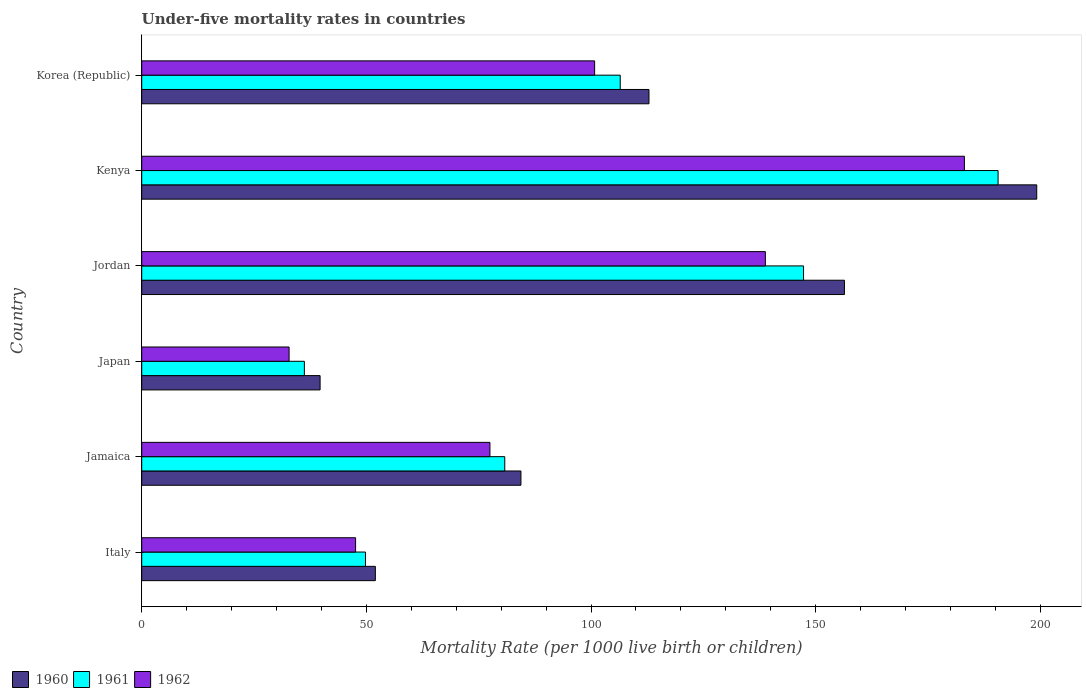How many different coloured bars are there?
Provide a succinct answer. 3. What is the label of the 5th group of bars from the top?
Your answer should be compact. Jamaica. In how many cases, is the number of bars for a given country not equal to the number of legend labels?
Provide a succinct answer. 0. What is the under-five mortality rate in 1960 in Japan?
Your answer should be very brief. 39.7. Across all countries, what is the maximum under-five mortality rate in 1962?
Provide a succinct answer. 183.1. Across all countries, what is the minimum under-five mortality rate in 1961?
Your response must be concise. 36.2. In which country was the under-five mortality rate in 1962 maximum?
Your answer should be very brief. Kenya. What is the total under-five mortality rate in 1960 in the graph?
Keep it short and to the point. 644.6. What is the difference between the under-five mortality rate in 1961 in Jamaica and that in Jordan?
Offer a very short reply. -66.5. What is the difference between the under-five mortality rate in 1962 in Jordan and the under-five mortality rate in 1960 in Jamaica?
Your answer should be compact. 54.4. What is the average under-five mortality rate in 1960 per country?
Your response must be concise. 107.43. What is the difference between the under-five mortality rate in 1962 and under-five mortality rate in 1961 in Korea (Republic)?
Provide a succinct answer. -5.7. In how many countries, is the under-five mortality rate in 1961 greater than 90 ?
Keep it short and to the point. 3. What is the ratio of the under-five mortality rate in 1962 in Jamaica to that in Korea (Republic)?
Your answer should be compact. 0.77. Is the under-five mortality rate in 1962 in Kenya less than that in Korea (Republic)?
Your answer should be compact. No. What is the difference between the highest and the second highest under-five mortality rate in 1960?
Your answer should be very brief. 42.8. What is the difference between the highest and the lowest under-five mortality rate in 1962?
Make the answer very short. 150.3. Is the sum of the under-five mortality rate in 1961 in Italy and Jamaica greater than the maximum under-five mortality rate in 1960 across all countries?
Offer a terse response. No. What does the 1st bar from the top in Kenya represents?
Keep it short and to the point. 1962. What does the 2nd bar from the bottom in Japan represents?
Your answer should be very brief. 1961. Is it the case that in every country, the sum of the under-five mortality rate in 1960 and under-five mortality rate in 1962 is greater than the under-five mortality rate in 1961?
Keep it short and to the point. Yes. Are all the bars in the graph horizontal?
Ensure brevity in your answer.  Yes. How many countries are there in the graph?
Your response must be concise. 6. What is the difference between two consecutive major ticks on the X-axis?
Your answer should be compact. 50. Does the graph contain any zero values?
Make the answer very short. No. What is the title of the graph?
Ensure brevity in your answer.  Under-five mortality rates in countries. What is the label or title of the X-axis?
Give a very brief answer. Mortality Rate (per 1000 live birth or children). What is the Mortality Rate (per 1000 live birth or children) of 1960 in Italy?
Provide a short and direct response. 52. What is the Mortality Rate (per 1000 live birth or children) of 1961 in Italy?
Provide a succinct answer. 49.8. What is the Mortality Rate (per 1000 live birth or children) in 1962 in Italy?
Your response must be concise. 47.6. What is the Mortality Rate (per 1000 live birth or children) of 1960 in Jamaica?
Make the answer very short. 84.4. What is the Mortality Rate (per 1000 live birth or children) in 1961 in Jamaica?
Ensure brevity in your answer.  80.8. What is the Mortality Rate (per 1000 live birth or children) of 1962 in Jamaica?
Ensure brevity in your answer.  77.5. What is the Mortality Rate (per 1000 live birth or children) in 1960 in Japan?
Ensure brevity in your answer.  39.7. What is the Mortality Rate (per 1000 live birth or children) of 1961 in Japan?
Offer a very short reply. 36.2. What is the Mortality Rate (per 1000 live birth or children) in 1962 in Japan?
Give a very brief answer. 32.8. What is the Mortality Rate (per 1000 live birth or children) of 1960 in Jordan?
Your answer should be compact. 156.4. What is the Mortality Rate (per 1000 live birth or children) in 1961 in Jordan?
Keep it short and to the point. 147.3. What is the Mortality Rate (per 1000 live birth or children) of 1962 in Jordan?
Your response must be concise. 138.8. What is the Mortality Rate (per 1000 live birth or children) in 1960 in Kenya?
Keep it short and to the point. 199.2. What is the Mortality Rate (per 1000 live birth or children) in 1961 in Kenya?
Give a very brief answer. 190.6. What is the Mortality Rate (per 1000 live birth or children) in 1962 in Kenya?
Offer a very short reply. 183.1. What is the Mortality Rate (per 1000 live birth or children) in 1960 in Korea (Republic)?
Make the answer very short. 112.9. What is the Mortality Rate (per 1000 live birth or children) of 1961 in Korea (Republic)?
Offer a terse response. 106.5. What is the Mortality Rate (per 1000 live birth or children) of 1962 in Korea (Republic)?
Offer a very short reply. 100.8. Across all countries, what is the maximum Mortality Rate (per 1000 live birth or children) in 1960?
Your response must be concise. 199.2. Across all countries, what is the maximum Mortality Rate (per 1000 live birth or children) in 1961?
Your answer should be very brief. 190.6. Across all countries, what is the maximum Mortality Rate (per 1000 live birth or children) of 1962?
Your answer should be very brief. 183.1. Across all countries, what is the minimum Mortality Rate (per 1000 live birth or children) of 1960?
Give a very brief answer. 39.7. Across all countries, what is the minimum Mortality Rate (per 1000 live birth or children) in 1961?
Provide a succinct answer. 36.2. Across all countries, what is the minimum Mortality Rate (per 1000 live birth or children) of 1962?
Keep it short and to the point. 32.8. What is the total Mortality Rate (per 1000 live birth or children) of 1960 in the graph?
Ensure brevity in your answer.  644.6. What is the total Mortality Rate (per 1000 live birth or children) in 1961 in the graph?
Ensure brevity in your answer.  611.2. What is the total Mortality Rate (per 1000 live birth or children) in 1962 in the graph?
Your response must be concise. 580.6. What is the difference between the Mortality Rate (per 1000 live birth or children) in 1960 in Italy and that in Jamaica?
Your answer should be very brief. -32.4. What is the difference between the Mortality Rate (per 1000 live birth or children) of 1961 in Italy and that in Jamaica?
Give a very brief answer. -31. What is the difference between the Mortality Rate (per 1000 live birth or children) of 1962 in Italy and that in Jamaica?
Keep it short and to the point. -29.9. What is the difference between the Mortality Rate (per 1000 live birth or children) of 1961 in Italy and that in Japan?
Your response must be concise. 13.6. What is the difference between the Mortality Rate (per 1000 live birth or children) in 1962 in Italy and that in Japan?
Ensure brevity in your answer.  14.8. What is the difference between the Mortality Rate (per 1000 live birth or children) of 1960 in Italy and that in Jordan?
Give a very brief answer. -104.4. What is the difference between the Mortality Rate (per 1000 live birth or children) of 1961 in Italy and that in Jordan?
Your answer should be compact. -97.5. What is the difference between the Mortality Rate (per 1000 live birth or children) of 1962 in Italy and that in Jordan?
Make the answer very short. -91.2. What is the difference between the Mortality Rate (per 1000 live birth or children) of 1960 in Italy and that in Kenya?
Provide a succinct answer. -147.2. What is the difference between the Mortality Rate (per 1000 live birth or children) of 1961 in Italy and that in Kenya?
Your answer should be very brief. -140.8. What is the difference between the Mortality Rate (per 1000 live birth or children) of 1962 in Italy and that in Kenya?
Your answer should be very brief. -135.5. What is the difference between the Mortality Rate (per 1000 live birth or children) of 1960 in Italy and that in Korea (Republic)?
Ensure brevity in your answer.  -60.9. What is the difference between the Mortality Rate (per 1000 live birth or children) in 1961 in Italy and that in Korea (Republic)?
Give a very brief answer. -56.7. What is the difference between the Mortality Rate (per 1000 live birth or children) in 1962 in Italy and that in Korea (Republic)?
Ensure brevity in your answer.  -53.2. What is the difference between the Mortality Rate (per 1000 live birth or children) in 1960 in Jamaica and that in Japan?
Provide a succinct answer. 44.7. What is the difference between the Mortality Rate (per 1000 live birth or children) of 1961 in Jamaica and that in Japan?
Your answer should be compact. 44.6. What is the difference between the Mortality Rate (per 1000 live birth or children) of 1962 in Jamaica and that in Japan?
Your answer should be very brief. 44.7. What is the difference between the Mortality Rate (per 1000 live birth or children) in 1960 in Jamaica and that in Jordan?
Provide a short and direct response. -72. What is the difference between the Mortality Rate (per 1000 live birth or children) in 1961 in Jamaica and that in Jordan?
Keep it short and to the point. -66.5. What is the difference between the Mortality Rate (per 1000 live birth or children) of 1962 in Jamaica and that in Jordan?
Your answer should be compact. -61.3. What is the difference between the Mortality Rate (per 1000 live birth or children) of 1960 in Jamaica and that in Kenya?
Ensure brevity in your answer.  -114.8. What is the difference between the Mortality Rate (per 1000 live birth or children) of 1961 in Jamaica and that in Kenya?
Ensure brevity in your answer.  -109.8. What is the difference between the Mortality Rate (per 1000 live birth or children) in 1962 in Jamaica and that in Kenya?
Offer a terse response. -105.6. What is the difference between the Mortality Rate (per 1000 live birth or children) in 1960 in Jamaica and that in Korea (Republic)?
Provide a short and direct response. -28.5. What is the difference between the Mortality Rate (per 1000 live birth or children) of 1961 in Jamaica and that in Korea (Republic)?
Offer a very short reply. -25.7. What is the difference between the Mortality Rate (per 1000 live birth or children) in 1962 in Jamaica and that in Korea (Republic)?
Your answer should be compact. -23.3. What is the difference between the Mortality Rate (per 1000 live birth or children) of 1960 in Japan and that in Jordan?
Provide a short and direct response. -116.7. What is the difference between the Mortality Rate (per 1000 live birth or children) of 1961 in Japan and that in Jordan?
Provide a succinct answer. -111.1. What is the difference between the Mortality Rate (per 1000 live birth or children) in 1962 in Japan and that in Jordan?
Your response must be concise. -106. What is the difference between the Mortality Rate (per 1000 live birth or children) of 1960 in Japan and that in Kenya?
Provide a short and direct response. -159.5. What is the difference between the Mortality Rate (per 1000 live birth or children) in 1961 in Japan and that in Kenya?
Provide a succinct answer. -154.4. What is the difference between the Mortality Rate (per 1000 live birth or children) of 1962 in Japan and that in Kenya?
Give a very brief answer. -150.3. What is the difference between the Mortality Rate (per 1000 live birth or children) of 1960 in Japan and that in Korea (Republic)?
Keep it short and to the point. -73.2. What is the difference between the Mortality Rate (per 1000 live birth or children) in 1961 in Japan and that in Korea (Republic)?
Offer a very short reply. -70.3. What is the difference between the Mortality Rate (per 1000 live birth or children) of 1962 in Japan and that in Korea (Republic)?
Offer a terse response. -68. What is the difference between the Mortality Rate (per 1000 live birth or children) in 1960 in Jordan and that in Kenya?
Provide a succinct answer. -42.8. What is the difference between the Mortality Rate (per 1000 live birth or children) in 1961 in Jordan and that in Kenya?
Your answer should be very brief. -43.3. What is the difference between the Mortality Rate (per 1000 live birth or children) of 1962 in Jordan and that in Kenya?
Offer a very short reply. -44.3. What is the difference between the Mortality Rate (per 1000 live birth or children) of 1960 in Jordan and that in Korea (Republic)?
Your answer should be compact. 43.5. What is the difference between the Mortality Rate (per 1000 live birth or children) in 1961 in Jordan and that in Korea (Republic)?
Provide a short and direct response. 40.8. What is the difference between the Mortality Rate (per 1000 live birth or children) of 1962 in Jordan and that in Korea (Republic)?
Your answer should be very brief. 38. What is the difference between the Mortality Rate (per 1000 live birth or children) of 1960 in Kenya and that in Korea (Republic)?
Provide a succinct answer. 86.3. What is the difference between the Mortality Rate (per 1000 live birth or children) of 1961 in Kenya and that in Korea (Republic)?
Keep it short and to the point. 84.1. What is the difference between the Mortality Rate (per 1000 live birth or children) of 1962 in Kenya and that in Korea (Republic)?
Your answer should be very brief. 82.3. What is the difference between the Mortality Rate (per 1000 live birth or children) of 1960 in Italy and the Mortality Rate (per 1000 live birth or children) of 1961 in Jamaica?
Provide a short and direct response. -28.8. What is the difference between the Mortality Rate (per 1000 live birth or children) of 1960 in Italy and the Mortality Rate (per 1000 live birth or children) of 1962 in Jamaica?
Ensure brevity in your answer.  -25.5. What is the difference between the Mortality Rate (per 1000 live birth or children) in 1961 in Italy and the Mortality Rate (per 1000 live birth or children) in 1962 in Jamaica?
Give a very brief answer. -27.7. What is the difference between the Mortality Rate (per 1000 live birth or children) of 1960 in Italy and the Mortality Rate (per 1000 live birth or children) of 1961 in Jordan?
Your answer should be compact. -95.3. What is the difference between the Mortality Rate (per 1000 live birth or children) in 1960 in Italy and the Mortality Rate (per 1000 live birth or children) in 1962 in Jordan?
Offer a terse response. -86.8. What is the difference between the Mortality Rate (per 1000 live birth or children) of 1961 in Italy and the Mortality Rate (per 1000 live birth or children) of 1962 in Jordan?
Your answer should be compact. -89. What is the difference between the Mortality Rate (per 1000 live birth or children) of 1960 in Italy and the Mortality Rate (per 1000 live birth or children) of 1961 in Kenya?
Keep it short and to the point. -138.6. What is the difference between the Mortality Rate (per 1000 live birth or children) of 1960 in Italy and the Mortality Rate (per 1000 live birth or children) of 1962 in Kenya?
Ensure brevity in your answer.  -131.1. What is the difference between the Mortality Rate (per 1000 live birth or children) of 1961 in Italy and the Mortality Rate (per 1000 live birth or children) of 1962 in Kenya?
Give a very brief answer. -133.3. What is the difference between the Mortality Rate (per 1000 live birth or children) of 1960 in Italy and the Mortality Rate (per 1000 live birth or children) of 1961 in Korea (Republic)?
Make the answer very short. -54.5. What is the difference between the Mortality Rate (per 1000 live birth or children) in 1960 in Italy and the Mortality Rate (per 1000 live birth or children) in 1962 in Korea (Republic)?
Your answer should be very brief. -48.8. What is the difference between the Mortality Rate (per 1000 live birth or children) of 1961 in Italy and the Mortality Rate (per 1000 live birth or children) of 1962 in Korea (Republic)?
Provide a succinct answer. -51. What is the difference between the Mortality Rate (per 1000 live birth or children) of 1960 in Jamaica and the Mortality Rate (per 1000 live birth or children) of 1961 in Japan?
Ensure brevity in your answer.  48.2. What is the difference between the Mortality Rate (per 1000 live birth or children) of 1960 in Jamaica and the Mortality Rate (per 1000 live birth or children) of 1962 in Japan?
Provide a succinct answer. 51.6. What is the difference between the Mortality Rate (per 1000 live birth or children) in 1960 in Jamaica and the Mortality Rate (per 1000 live birth or children) in 1961 in Jordan?
Your answer should be very brief. -62.9. What is the difference between the Mortality Rate (per 1000 live birth or children) of 1960 in Jamaica and the Mortality Rate (per 1000 live birth or children) of 1962 in Jordan?
Ensure brevity in your answer.  -54.4. What is the difference between the Mortality Rate (per 1000 live birth or children) of 1961 in Jamaica and the Mortality Rate (per 1000 live birth or children) of 1962 in Jordan?
Provide a short and direct response. -58. What is the difference between the Mortality Rate (per 1000 live birth or children) of 1960 in Jamaica and the Mortality Rate (per 1000 live birth or children) of 1961 in Kenya?
Provide a succinct answer. -106.2. What is the difference between the Mortality Rate (per 1000 live birth or children) of 1960 in Jamaica and the Mortality Rate (per 1000 live birth or children) of 1962 in Kenya?
Give a very brief answer. -98.7. What is the difference between the Mortality Rate (per 1000 live birth or children) of 1961 in Jamaica and the Mortality Rate (per 1000 live birth or children) of 1962 in Kenya?
Your response must be concise. -102.3. What is the difference between the Mortality Rate (per 1000 live birth or children) in 1960 in Jamaica and the Mortality Rate (per 1000 live birth or children) in 1961 in Korea (Republic)?
Provide a succinct answer. -22.1. What is the difference between the Mortality Rate (per 1000 live birth or children) of 1960 in Jamaica and the Mortality Rate (per 1000 live birth or children) of 1962 in Korea (Republic)?
Your answer should be very brief. -16.4. What is the difference between the Mortality Rate (per 1000 live birth or children) in 1961 in Jamaica and the Mortality Rate (per 1000 live birth or children) in 1962 in Korea (Republic)?
Keep it short and to the point. -20. What is the difference between the Mortality Rate (per 1000 live birth or children) of 1960 in Japan and the Mortality Rate (per 1000 live birth or children) of 1961 in Jordan?
Offer a very short reply. -107.6. What is the difference between the Mortality Rate (per 1000 live birth or children) in 1960 in Japan and the Mortality Rate (per 1000 live birth or children) in 1962 in Jordan?
Give a very brief answer. -99.1. What is the difference between the Mortality Rate (per 1000 live birth or children) in 1961 in Japan and the Mortality Rate (per 1000 live birth or children) in 1962 in Jordan?
Keep it short and to the point. -102.6. What is the difference between the Mortality Rate (per 1000 live birth or children) of 1960 in Japan and the Mortality Rate (per 1000 live birth or children) of 1961 in Kenya?
Provide a succinct answer. -150.9. What is the difference between the Mortality Rate (per 1000 live birth or children) of 1960 in Japan and the Mortality Rate (per 1000 live birth or children) of 1962 in Kenya?
Offer a terse response. -143.4. What is the difference between the Mortality Rate (per 1000 live birth or children) in 1961 in Japan and the Mortality Rate (per 1000 live birth or children) in 1962 in Kenya?
Offer a terse response. -146.9. What is the difference between the Mortality Rate (per 1000 live birth or children) in 1960 in Japan and the Mortality Rate (per 1000 live birth or children) in 1961 in Korea (Republic)?
Offer a terse response. -66.8. What is the difference between the Mortality Rate (per 1000 live birth or children) in 1960 in Japan and the Mortality Rate (per 1000 live birth or children) in 1962 in Korea (Republic)?
Provide a short and direct response. -61.1. What is the difference between the Mortality Rate (per 1000 live birth or children) of 1961 in Japan and the Mortality Rate (per 1000 live birth or children) of 1962 in Korea (Republic)?
Offer a terse response. -64.6. What is the difference between the Mortality Rate (per 1000 live birth or children) of 1960 in Jordan and the Mortality Rate (per 1000 live birth or children) of 1961 in Kenya?
Your answer should be compact. -34.2. What is the difference between the Mortality Rate (per 1000 live birth or children) in 1960 in Jordan and the Mortality Rate (per 1000 live birth or children) in 1962 in Kenya?
Your response must be concise. -26.7. What is the difference between the Mortality Rate (per 1000 live birth or children) of 1961 in Jordan and the Mortality Rate (per 1000 live birth or children) of 1962 in Kenya?
Your answer should be compact. -35.8. What is the difference between the Mortality Rate (per 1000 live birth or children) in 1960 in Jordan and the Mortality Rate (per 1000 live birth or children) in 1961 in Korea (Republic)?
Keep it short and to the point. 49.9. What is the difference between the Mortality Rate (per 1000 live birth or children) in 1960 in Jordan and the Mortality Rate (per 1000 live birth or children) in 1962 in Korea (Republic)?
Provide a succinct answer. 55.6. What is the difference between the Mortality Rate (per 1000 live birth or children) of 1961 in Jordan and the Mortality Rate (per 1000 live birth or children) of 1962 in Korea (Republic)?
Ensure brevity in your answer.  46.5. What is the difference between the Mortality Rate (per 1000 live birth or children) in 1960 in Kenya and the Mortality Rate (per 1000 live birth or children) in 1961 in Korea (Republic)?
Offer a terse response. 92.7. What is the difference between the Mortality Rate (per 1000 live birth or children) in 1960 in Kenya and the Mortality Rate (per 1000 live birth or children) in 1962 in Korea (Republic)?
Your answer should be very brief. 98.4. What is the difference between the Mortality Rate (per 1000 live birth or children) in 1961 in Kenya and the Mortality Rate (per 1000 live birth or children) in 1962 in Korea (Republic)?
Make the answer very short. 89.8. What is the average Mortality Rate (per 1000 live birth or children) in 1960 per country?
Provide a short and direct response. 107.43. What is the average Mortality Rate (per 1000 live birth or children) of 1961 per country?
Keep it short and to the point. 101.87. What is the average Mortality Rate (per 1000 live birth or children) in 1962 per country?
Your response must be concise. 96.77. What is the difference between the Mortality Rate (per 1000 live birth or children) in 1960 and Mortality Rate (per 1000 live birth or children) in 1961 in Italy?
Offer a very short reply. 2.2. What is the difference between the Mortality Rate (per 1000 live birth or children) of 1961 and Mortality Rate (per 1000 live birth or children) of 1962 in Italy?
Make the answer very short. 2.2. What is the difference between the Mortality Rate (per 1000 live birth or children) in 1960 and Mortality Rate (per 1000 live birth or children) in 1962 in Jamaica?
Keep it short and to the point. 6.9. What is the difference between the Mortality Rate (per 1000 live birth or children) in 1960 and Mortality Rate (per 1000 live birth or children) in 1962 in Japan?
Your response must be concise. 6.9. What is the difference between the Mortality Rate (per 1000 live birth or children) of 1961 and Mortality Rate (per 1000 live birth or children) of 1962 in Japan?
Provide a succinct answer. 3.4. What is the difference between the Mortality Rate (per 1000 live birth or children) of 1960 and Mortality Rate (per 1000 live birth or children) of 1962 in Jordan?
Give a very brief answer. 17.6. What is the difference between the Mortality Rate (per 1000 live birth or children) of 1960 and Mortality Rate (per 1000 live birth or children) of 1961 in Kenya?
Your response must be concise. 8.6. What is the difference between the Mortality Rate (per 1000 live birth or children) in 1960 and Mortality Rate (per 1000 live birth or children) in 1961 in Korea (Republic)?
Offer a terse response. 6.4. What is the difference between the Mortality Rate (per 1000 live birth or children) of 1960 and Mortality Rate (per 1000 live birth or children) of 1962 in Korea (Republic)?
Make the answer very short. 12.1. What is the ratio of the Mortality Rate (per 1000 live birth or children) in 1960 in Italy to that in Jamaica?
Offer a very short reply. 0.62. What is the ratio of the Mortality Rate (per 1000 live birth or children) of 1961 in Italy to that in Jamaica?
Ensure brevity in your answer.  0.62. What is the ratio of the Mortality Rate (per 1000 live birth or children) in 1962 in Italy to that in Jamaica?
Your answer should be very brief. 0.61. What is the ratio of the Mortality Rate (per 1000 live birth or children) in 1960 in Italy to that in Japan?
Offer a very short reply. 1.31. What is the ratio of the Mortality Rate (per 1000 live birth or children) in 1961 in Italy to that in Japan?
Provide a succinct answer. 1.38. What is the ratio of the Mortality Rate (per 1000 live birth or children) in 1962 in Italy to that in Japan?
Ensure brevity in your answer.  1.45. What is the ratio of the Mortality Rate (per 1000 live birth or children) in 1960 in Italy to that in Jordan?
Give a very brief answer. 0.33. What is the ratio of the Mortality Rate (per 1000 live birth or children) in 1961 in Italy to that in Jordan?
Give a very brief answer. 0.34. What is the ratio of the Mortality Rate (per 1000 live birth or children) in 1962 in Italy to that in Jordan?
Provide a short and direct response. 0.34. What is the ratio of the Mortality Rate (per 1000 live birth or children) of 1960 in Italy to that in Kenya?
Offer a terse response. 0.26. What is the ratio of the Mortality Rate (per 1000 live birth or children) in 1961 in Italy to that in Kenya?
Your answer should be very brief. 0.26. What is the ratio of the Mortality Rate (per 1000 live birth or children) of 1962 in Italy to that in Kenya?
Your response must be concise. 0.26. What is the ratio of the Mortality Rate (per 1000 live birth or children) of 1960 in Italy to that in Korea (Republic)?
Your answer should be very brief. 0.46. What is the ratio of the Mortality Rate (per 1000 live birth or children) of 1961 in Italy to that in Korea (Republic)?
Give a very brief answer. 0.47. What is the ratio of the Mortality Rate (per 1000 live birth or children) of 1962 in Italy to that in Korea (Republic)?
Make the answer very short. 0.47. What is the ratio of the Mortality Rate (per 1000 live birth or children) in 1960 in Jamaica to that in Japan?
Provide a succinct answer. 2.13. What is the ratio of the Mortality Rate (per 1000 live birth or children) in 1961 in Jamaica to that in Japan?
Offer a terse response. 2.23. What is the ratio of the Mortality Rate (per 1000 live birth or children) of 1962 in Jamaica to that in Japan?
Your answer should be very brief. 2.36. What is the ratio of the Mortality Rate (per 1000 live birth or children) in 1960 in Jamaica to that in Jordan?
Keep it short and to the point. 0.54. What is the ratio of the Mortality Rate (per 1000 live birth or children) in 1961 in Jamaica to that in Jordan?
Your answer should be very brief. 0.55. What is the ratio of the Mortality Rate (per 1000 live birth or children) in 1962 in Jamaica to that in Jordan?
Give a very brief answer. 0.56. What is the ratio of the Mortality Rate (per 1000 live birth or children) in 1960 in Jamaica to that in Kenya?
Ensure brevity in your answer.  0.42. What is the ratio of the Mortality Rate (per 1000 live birth or children) of 1961 in Jamaica to that in Kenya?
Ensure brevity in your answer.  0.42. What is the ratio of the Mortality Rate (per 1000 live birth or children) in 1962 in Jamaica to that in Kenya?
Give a very brief answer. 0.42. What is the ratio of the Mortality Rate (per 1000 live birth or children) in 1960 in Jamaica to that in Korea (Republic)?
Your answer should be compact. 0.75. What is the ratio of the Mortality Rate (per 1000 live birth or children) in 1961 in Jamaica to that in Korea (Republic)?
Offer a very short reply. 0.76. What is the ratio of the Mortality Rate (per 1000 live birth or children) of 1962 in Jamaica to that in Korea (Republic)?
Give a very brief answer. 0.77. What is the ratio of the Mortality Rate (per 1000 live birth or children) of 1960 in Japan to that in Jordan?
Offer a terse response. 0.25. What is the ratio of the Mortality Rate (per 1000 live birth or children) of 1961 in Japan to that in Jordan?
Your response must be concise. 0.25. What is the ratio of the Mortality Rate (per 1000 live birth or children) in 1962 in Japan to that in Jordan?
Your answer should be very brief. 0.24. What is the ratio of the Mortality Rate (per 1000 live birth or children) of 1960 in Japan to that in Kenya?
Provide a short and direct response. 0.2. What is the ratio of the Mortality Rate (per 1000 live birth or children) in 1961 in Japan to that in Kenya?
Provide a succinct answer. 0.19. What is the ratio of the Mortality Rate (per 1000 live birth or children) in 1962 in Japan to that in Kenya?
Offer a very short reply. 0.18. What is the ratio of the Mortality Rate (per 1000 live birth or children) of 1960 in Japan to that in Korea (Republic)?
Give a very brief answer. 0.35. What is the ratio of the Mortality Rate (per 1000 live birth or children) in 1961 in Japan to that in Korea (Republic)?
Make the answer very short. 0.34. What is the ratio of the Mortality Rate (per 1000 live birth or children) in 1962 in Japan to that in Korea (Republic)?
Make the answer very short. 0.33. What is the ratio of the Mortality Rate (per 1000 live birth or children) in 1960 in Jordan to that in Kenya?
Your answer should be compact. 0.79. What is the ratio of the Mortality Rate (per 1000 live birth or children) in 1961 in Jordan to that in Kenya?
Offer a terse response. 0.77. What is the ratio of the Mortality Rate (per 1000 live birth or children) in 1962 in Jordan to that in Kenya?
Your answer should be very brief. 0.76. What is the ratio of the Mortality Rate (per 1000 live birth or children) in 1960 in Jordan to that in Korea (Republic)?
Provide a short and direct response. 1.39. What is the ratio of the Mortality Rate (per 1000 live birth or children) in 1961 in Jordan to that in Korea (Republic)?
Offer a terse response. 1.38. What is the ratio of the Mortality Rate (per 1000 live birth or children) in 1962 in Jordan to that in Korea (Republic)?
Your answer should be very brief. 1.38. What is the ratio of the Mortality Rate (per 1000 live birth or children) of 1960 in Kenya to that in Korea (Republic)?
Your answer should be compact. 1.76. What is the ratio of the Mortality Rate (per 1000 live birth or children) of 1961 in Kenya to that in Korea (Republic)?
Provide a short and direct response. 1.79. What is the ratio of the Mortality Rate (per 1000 live birth or children) of 1962 in Kenya to that in Korea (Republic)?
Offer a very short reply. 1.82. What is the difference between the highest and the second highest Mortality Rate (per 1000 live birth or children) in 1960?
Offer a very short reply. 42.8. What is the difference between the highest and the second highest Mortality Rate (per 1000 live birth or children) in 1961?
Your answer should be very brief. 43.3. What is the difference between the highest and the second highest Mortality Rate (per 1000 live birth or children) of 1962?
Your answer should be compact. 44.3. What is the difference between the highest and the lowest Mortality Rate (per 1000 live birth or children) of 1960?
Your answer should be very brief. 159.5. What is the difference between the highest and the lowest Mortality Rate (per 1000 live birth or children) in 1961?
Your response must be concise. 154.4. What is the difference between the highest and the lowest Mortality Rate (per 1000 live birth or children) of 1962?
Provide a short and direct response. 150.3. 